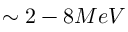Convert formula to latex. <formula><loc_0><loc_0><loc_500><loc_500>\sim 2 - 8 M e V</formula> 